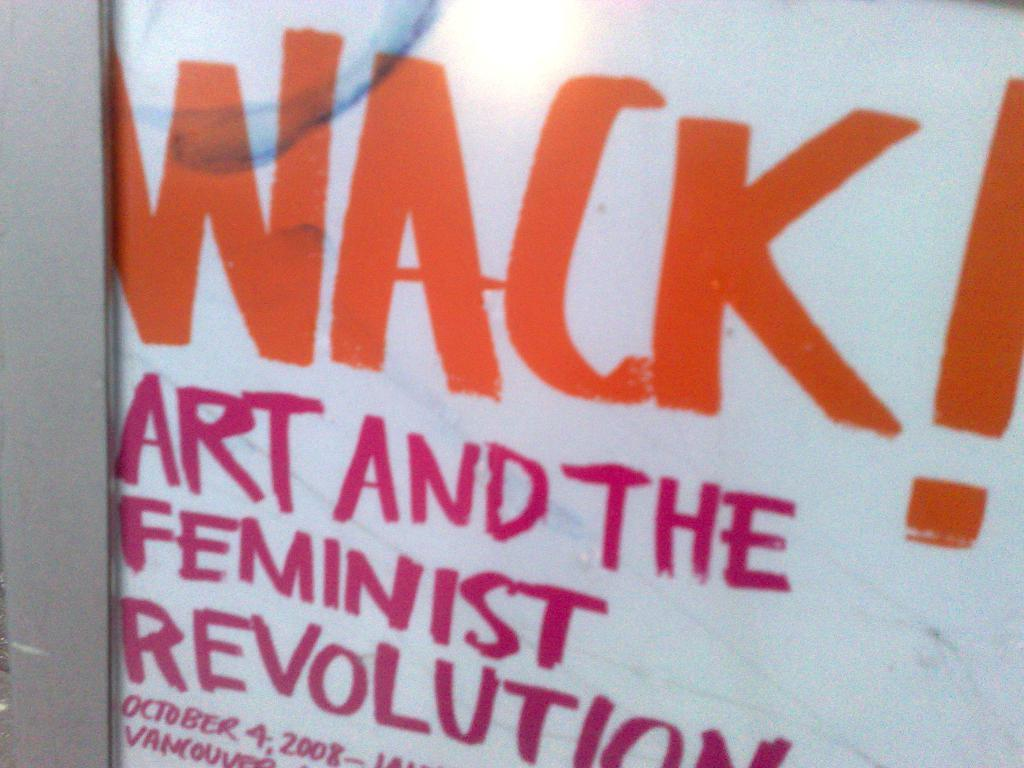<image>
Describe the image concisely. A poster about the feminist revolution says "WACK!" in big red letters. 